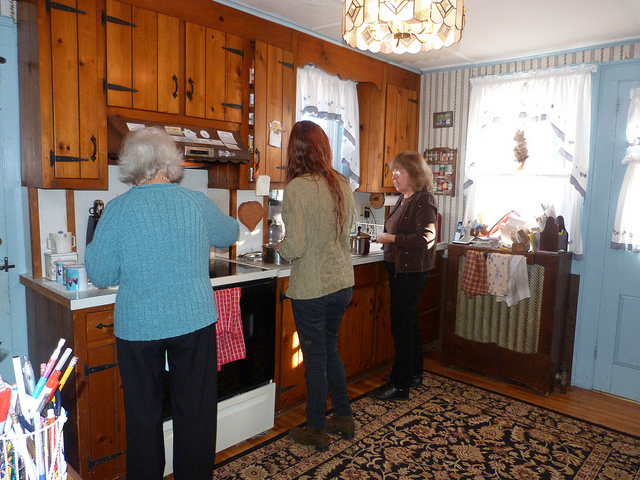How many people are in the photo? There are three people in the photo, each engaged in different activities within what appears to be a cozy kitchen setting. 